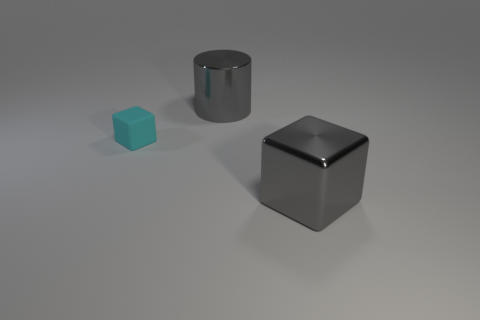Add 3 big cyan rubber objects. How many objects exist? 6 Subtract all cubes. How many objects are left? 1 Subtract all tiny cyan matte cubes. Subtract all small cyan things. How many objects are left? 1 Add 2 cyan objects. How many cyan objects are left? 3 Add 1 rubber things. How many rubber things exist? 2 Subtract 0 red blocks. How many objects are left? 3 